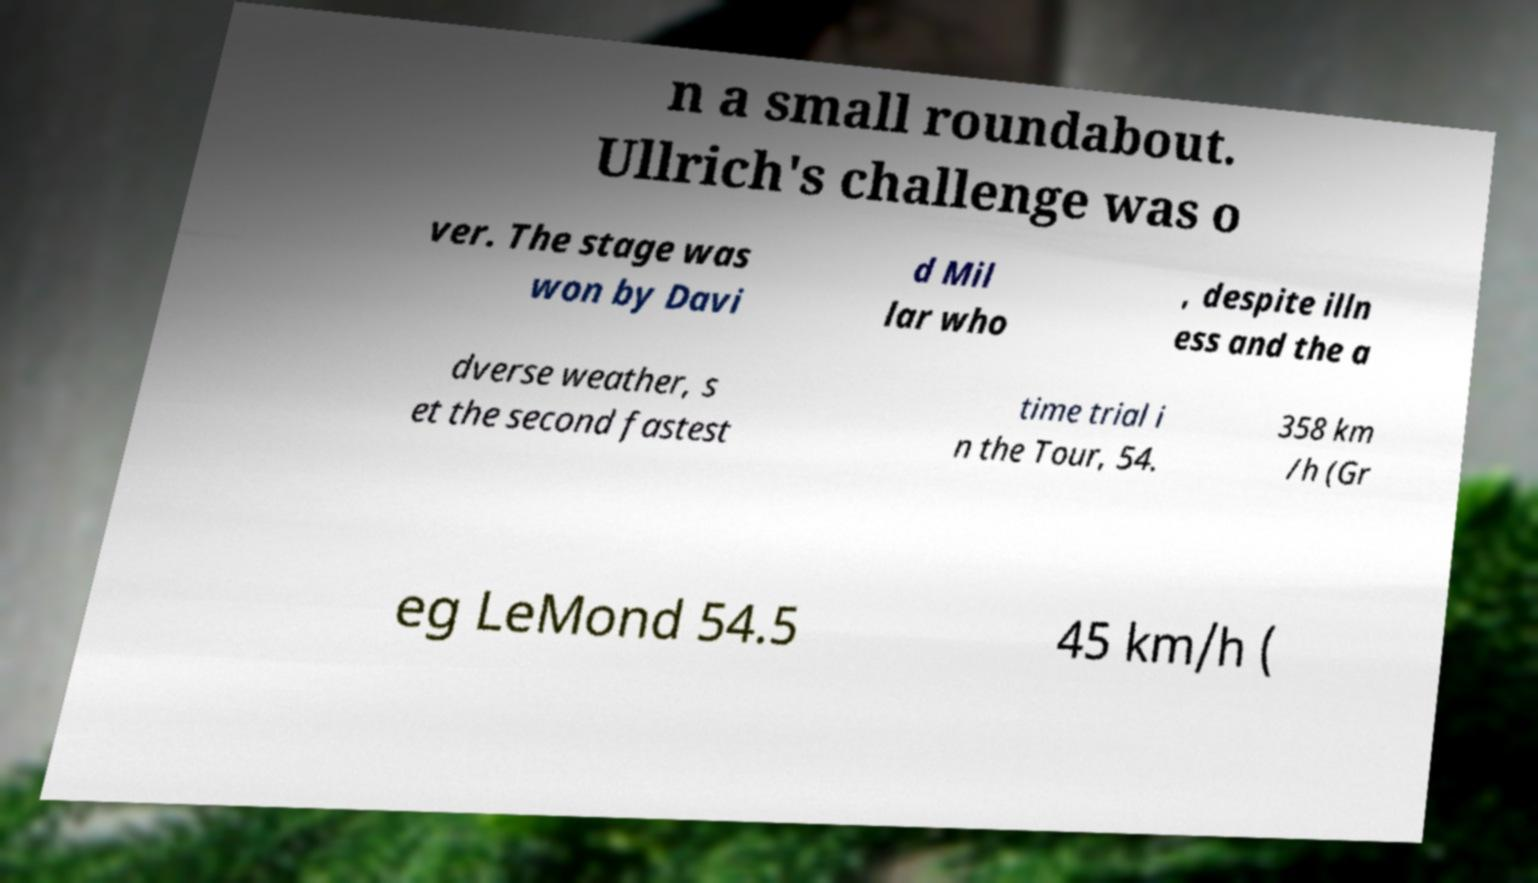I need the written content from this picture converted into text. Can you do that? n a small roundabout. Ullrich's challenge was o ver. The stage was won by Davi d Mil lar who , despite illn ess and the a dverse weather, s et the second fastest time trial i n the Tour, 54. 358 km /h (Gr eg LeMond 54.5 45 km/h ( 